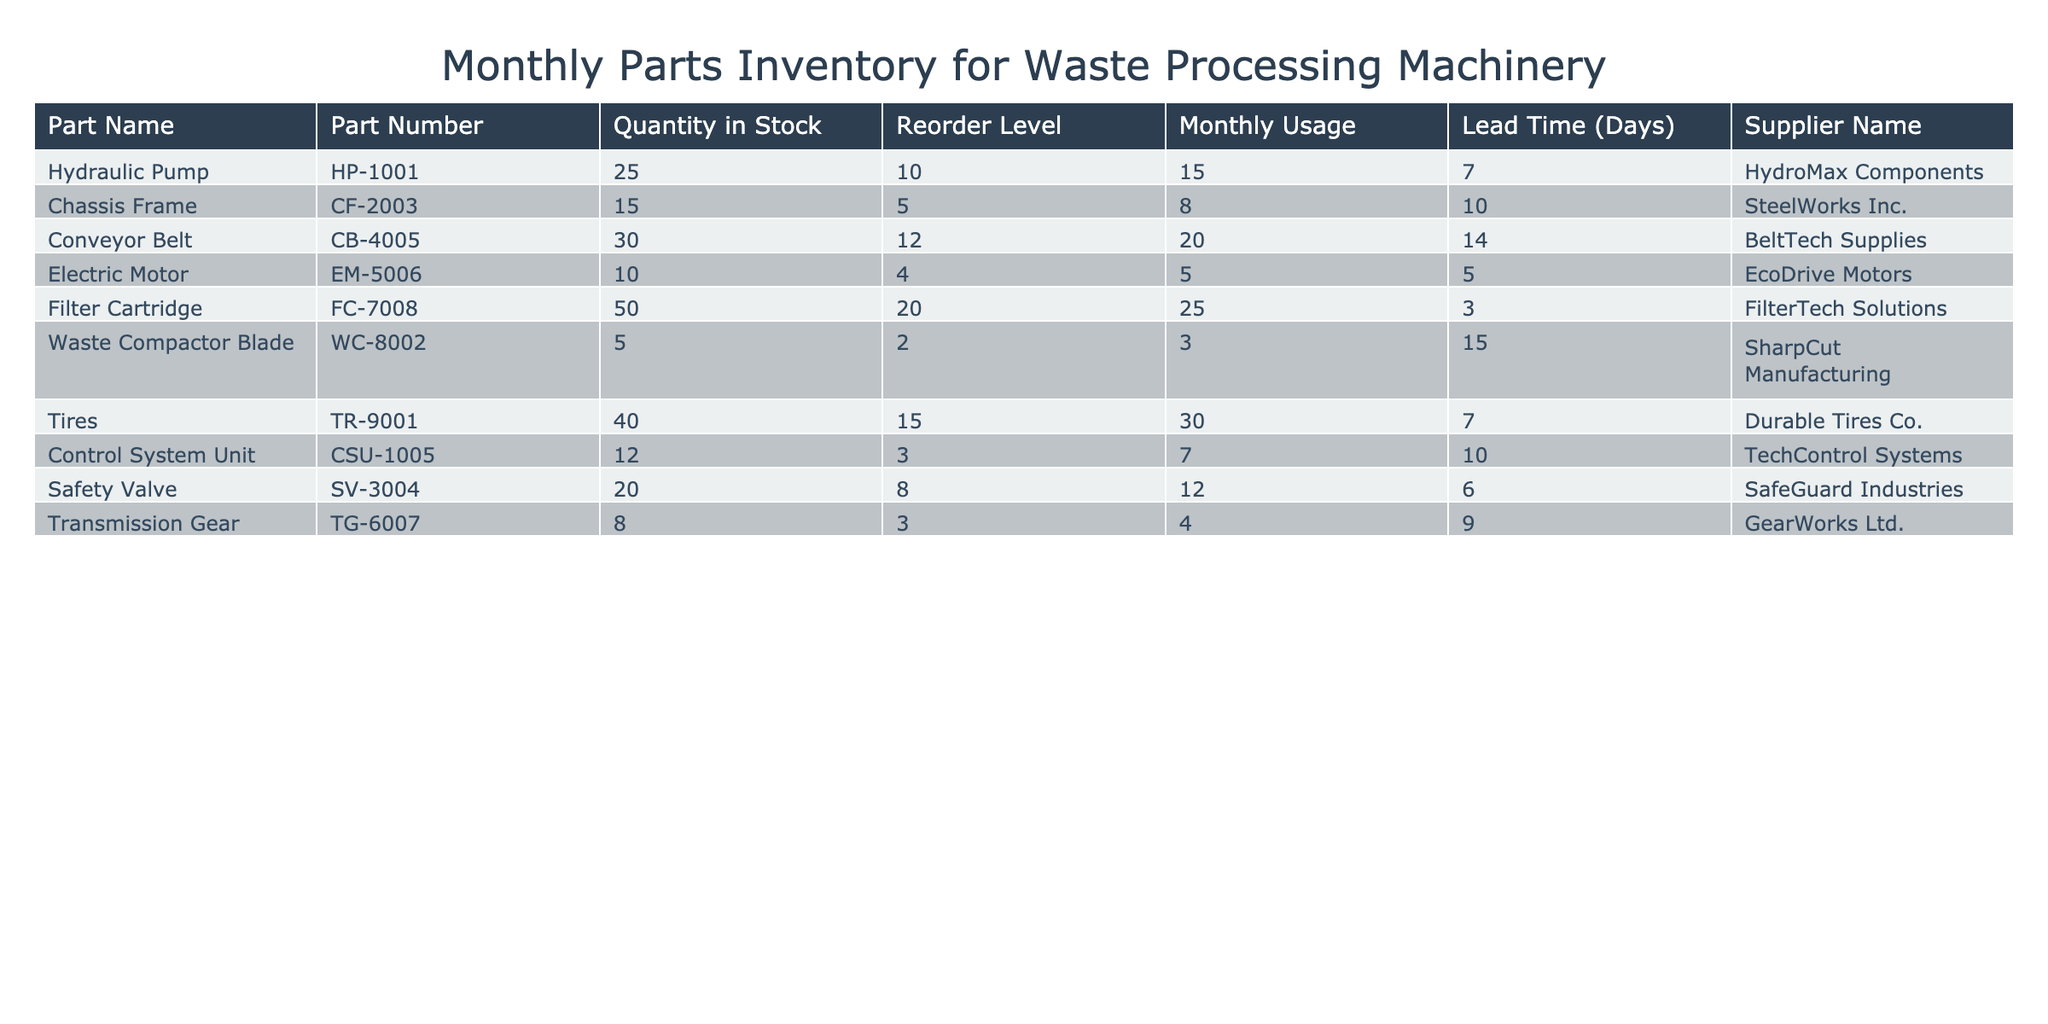What's the quantity of Electric Motors in stock? The table lists a part named "Electric Motor" with the corresponding "Quantity in Stock" value. Referring to that row, the quantity is 10.
Answer: 10 What is the reorder level for Hydraulic Pumps? The table specifies a reorder level for each part. For "Hydraulic Pump," this value is given directly in the row as 10.
Answer: 10 How many parts have a quantity in stock below their reorder level? To determine this, we check each part's "Quantity in Stock" against its "Reorder Level." The parts with quantities below the reorder levels are "Electric Motor" (10 < 4), "Waste Compactor Blade" (5 < 2), "Transmission Gear" (8 < 3). Thus, there are 3 parts that meet this condition.
Answer: 3 What is the total monthly usage of all parts? We sum the "Monthly Usage" values from each row in the table. The total is calculated as 15 (Hydraulic Pump) + 8 (Chassis Frame) + 20 (Conveyor Belt) + 5 (Electric Motor) + 25 (Filter Cartridge) + 3 (Waste Compactor Blade) + 30 (Tires) + 7 (Control System Unit) + 12 (Safety Valve) + 4 (Transmission Gear) = 129.
Answer: 129 Which part has the highest lead time and what is that lead time? We examine the "Lead Time (Days)" column, finding the maximum value. The "Waste Compactor Blade" has the highest lead time at 15 days.
Answer: 15 days Is the average quantity in stock of all parts above 20? First, we find the total quantity in stock which sums to 25 (Hydraulic Pump) + 15 (Chassis Frame) + 30 (Conveyor Belt) + 10 (Electric Motor) + 50 (Filter Cartridge) + 5 (Waste Compactor Blade) + 40 (Tires) + 12 (Control System Unit) + 20 (Safety Valve) + 8 (Transmission Gear) = 215. There are 10 items, thus the average is 215/10 = 21.5, which is above 20.
Answer: Yes How many days is the lead time for parts supplied by SteelWorks Inc.? Looking at the "Supplier Name" column, we find "SteelWorks Inc." supplies the "Chassis Frame," which has a lead time of 10 days as listed in the "Lead Time (Days)" column.
Answer: 10 days Identify the part with the lowest monthly usage. From the "Monthly Usage" column, comparing all values, we see "Waste Compactor Blade" has the lowest value at 3.
Answer: Waste Compactor Blade 